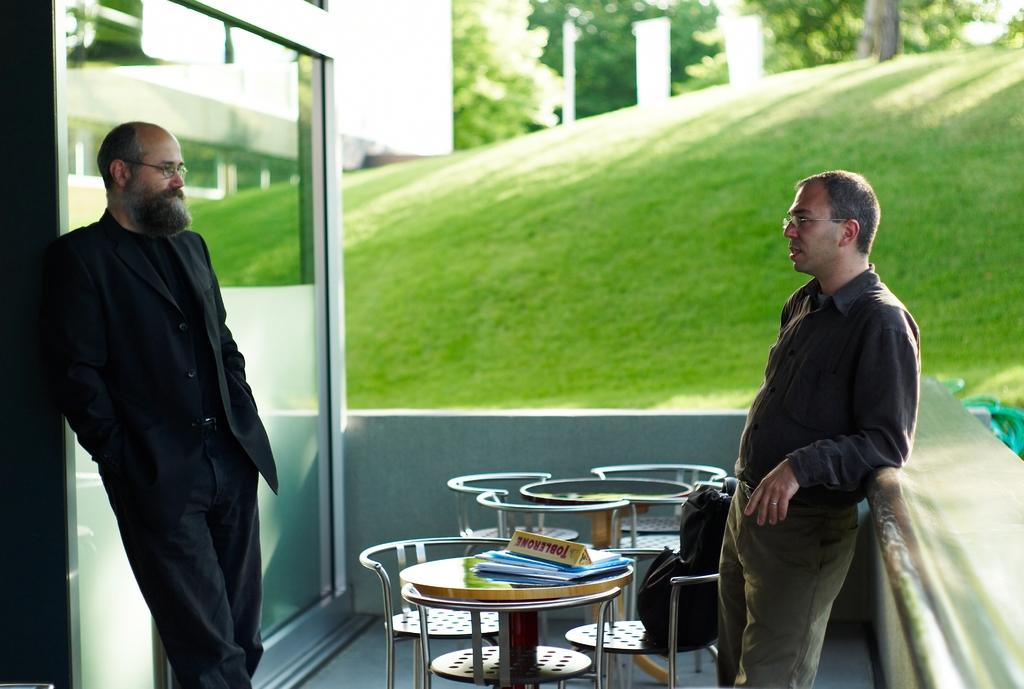How many people are in the image? There are 2 people in the image. What are the people doing in the image? The people are standing and talking to each other. What is in the center of the image? There is a table and chairs in the center of the image. What is on the table? There is a chocolate on the table. What type of natural environment is visible in the image? There is grass visible in the image, and trees are in the background. What type of pin can be seen holding the afterthought to the trip in the image? There is no pin, afterthought, or trip present in the image. 